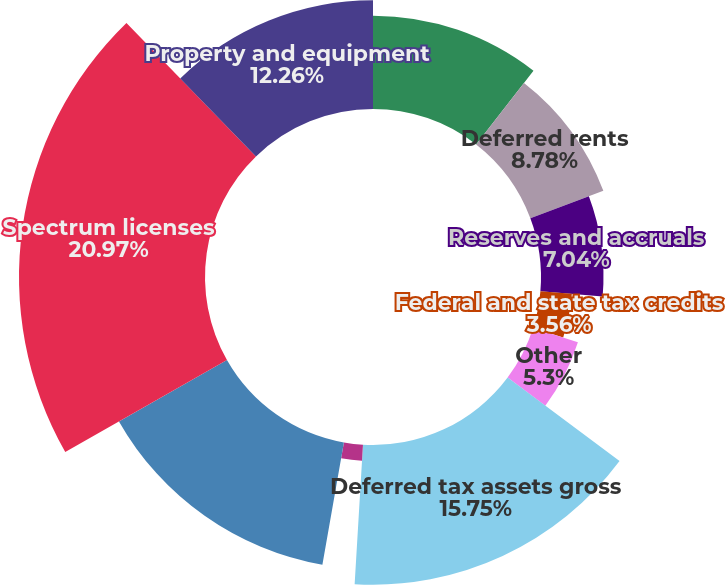<chart> <loc_0><loc_0><loc_500><loc_500><pie_chart><fcel>Loss carryforwards<fcel>Deferred rents<fcel>Reserves and accruals<fcel>Federal and state tax credits<fcel>Other<fcel>Deferred tax assets gross<fcel>Valuation allowance<fcel>Deferred tax assets net<fcel>Spectrum licenses<fcel>Property and equipment<nl><fcel>10.52%<fcel>8.78%<fcel>7.04%<fcel>3.56%<fcel>5.3%<fcel>15.74%<fcel>1.82%<fcel>14.0%<fcel>20.96%<fcel>12.26%<nl></chart> 